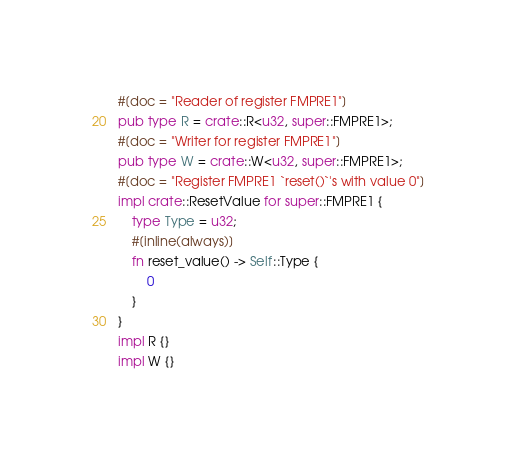Convert code to text. <code><loc_0><loc_0><loc_500><loc_500><_Rust_>#[doc = "Reader of register FMPRE1"]
pub type R = crate::R<u32, super::FMPRE1>;
#[doc = "Writer for register FMPRE1"]
pub type W = crate::W<u32, super::FMPRE1>;
#[doc = "Register FMPRE1 `reset()`'s with value 0"]
impl crate::ResetValue for super::FMPRE1 {
    type Type = u32;
    #[inline(always)]
    fn reset_value() -> Self::Type {
        0
    }
}
impl R {}
impl W {}
</code> 